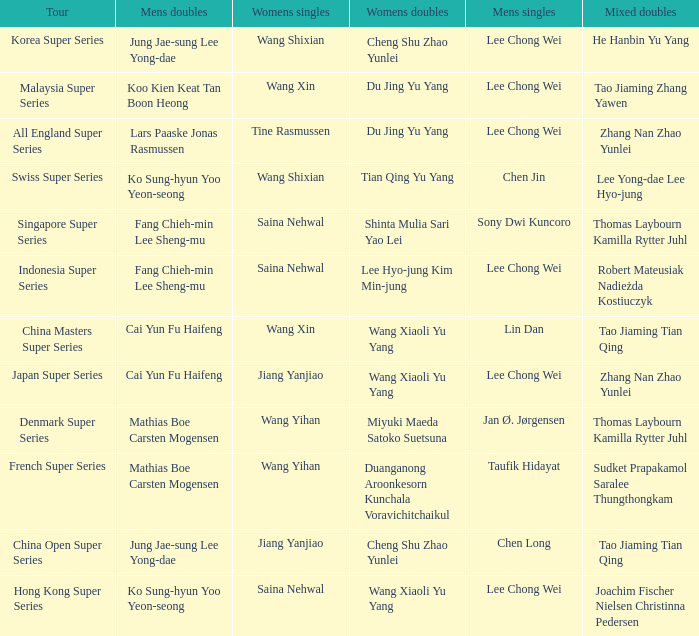Who were the womens doubles when the mixed doubles were zhang nan zhao yunlei on the tour all england super series? Du Jing Yu Yang. 